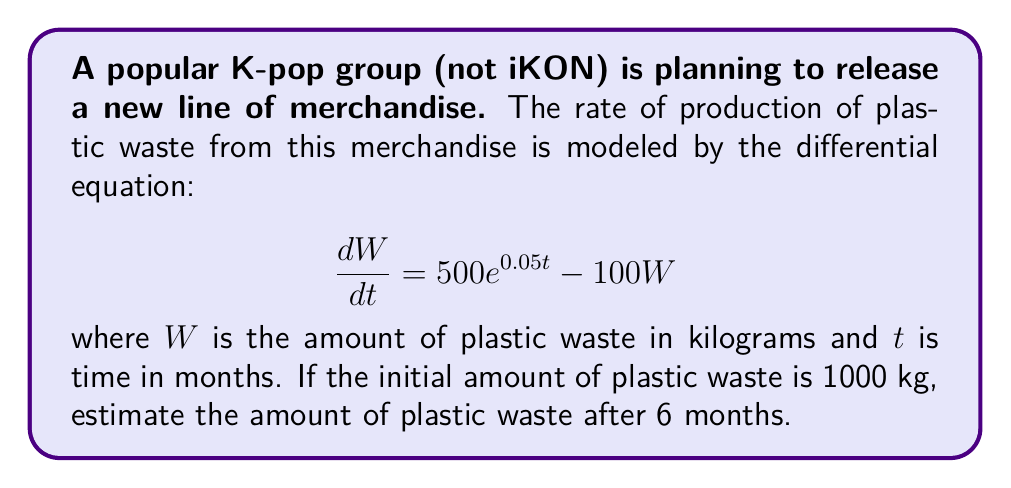Show me your answer to this math problem. To solve this problem, we need to use the method for solving first-order linear differential equations.

1) The general form of a first-order linear differential equation is:

   $$\frac{dW}{dt} + P(t)W = Q(t)$$

2) In our case, $P(t) = 100$ and $Q(t) = 500e^{0.05t}$

3) The integrating factor is $e^{\int P(t)dt} = e^{100t}$

4) Multiplying both sides of the equation by the integrating factor:

   $$e^{100t}\frac{dW}{dt} + 100e^{100t}W = 500e^{100t}e^{0.05t}$$

5) This can be rewritten as:

   $$\frac{d}{dt}(e^{100t}W) = 500e^{100.05t}$$

6) Integrating both sides:

   $$e^{100t}W = \frac{500}{100.05}e^{100.05t} + C$$

7) Solving for W:

   $$W = \frac{500}{100.05}e^{0.05t} + Ce^{-100t}$$

8) Using the initial condition $W(0) = 1000$, we can find C:

   $$1000 = \frac{500}{100.05} + C$$
   $$C = 1000 - \frac{500}{100.05} \approx 995.01$$

9) Therefore, the particular solution is:

   $$W = \frac{500}{100.05}e^{0.05t} + 995.01e^{-100t}$$

10) To find W(6), we substitute t = 6:

    $$W(6) = \frac{500}{100.05}e^{0.3} + 995.01e^{-600}$$

11) Calculating this value:

    $$W(6) \approx 5.2495 + 0 \approx 5.25 \text{ kg}$$
Answer: The amount of plastic waste after 6 months is approximately 5.25 kg. 